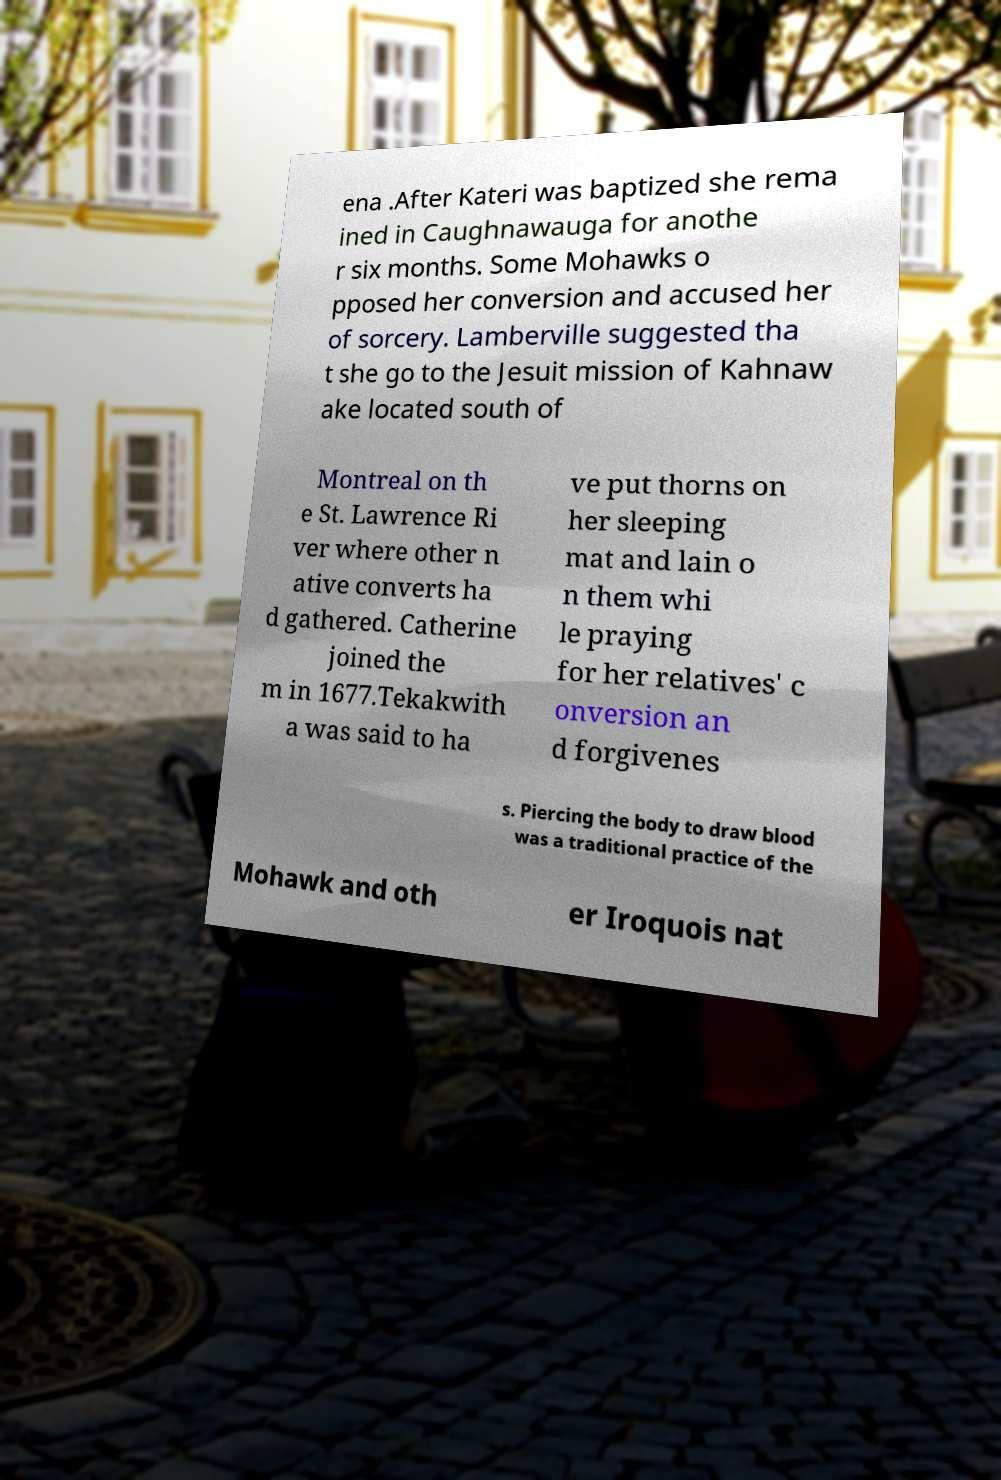There's text embedded in this image that I need extracted. Can you transcribe it verbatim? ena .After Kateri was baptized she rema ined in Caughnawauga for anothe r six months. Some Mohawks o pposed her conversion and accused her of sorcery. Lamberville suggested tha t she go to the Jesuit mission of Kahnaw ake located south of Montreal on th e St. Lawrence Ri ver where other n ative converts ha d gathered. Catherine joined the m in 1677.Tekakwith a was said to ha ve put thorns on her sleeping mat and lain o n them whi le praying for her relatives' c onversion an d forgivenes s. Piercing the body to draw blood was a traditional practice of the Mohawk and oth er Iroquois nat 